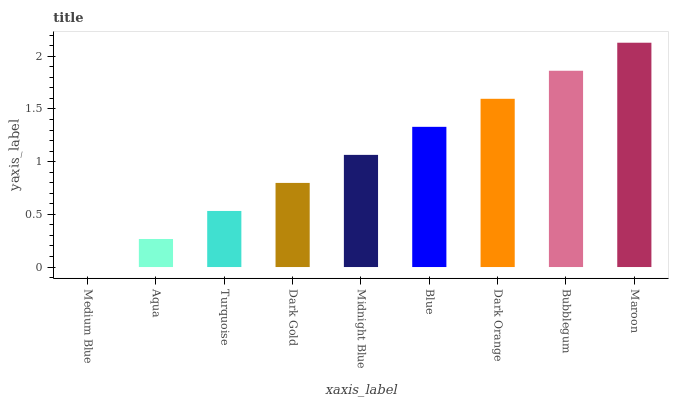Is Medium Blue the minimum?
Answer yes or no. Yes. Is Maroon the maximum?
Answer yes or no. Yes. Is Aqua the minimum?
Answer yes or no. No. Is Aqua the maximum?
Answer yes or no. No. Is Aqua greater than Medium Blue?
Answer yes or no. Yes. Is Medium Blue less than Aqua?
Answer yes or no. Yes. Is Medium Blue greater than Aqua?
Answer yes or no. No. Is Aqua less than Medium Blue?
Answer yes or no. No. Is Midnight Blue the high median?
Answer yes or no. Yes. Is Midnight Blue the low median?
Answer yes or no. Yes. Is Dark Orange the high median?
Answer yes or no. No. Is Dark Gold the low median?
Answer yes or no. No. 